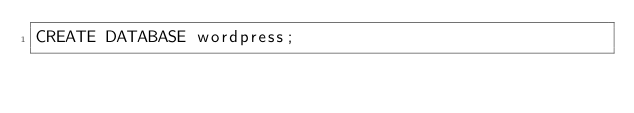Convert code to text. <code><loc_0><loc_0><loc_500><loc_500><_SQL_>CREATE DATABASE wordpress;</code> 